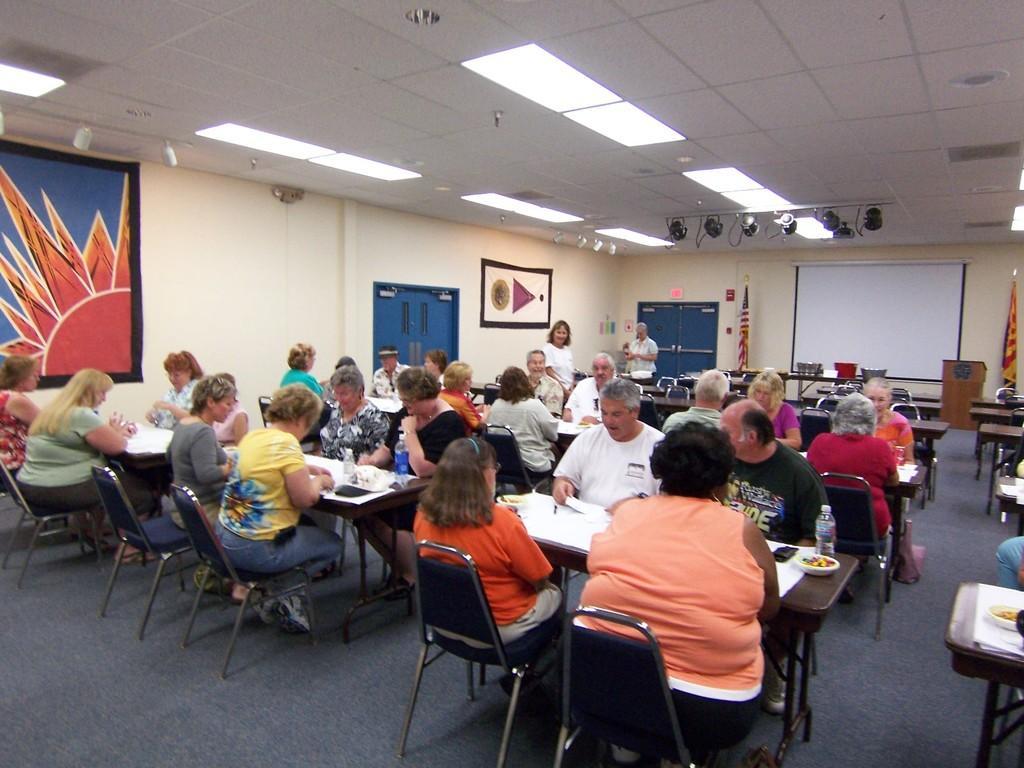How would you summarize this image in a sentence or two? In this image we can see persons sitting and standing on the chairs and tables are placed in front of them. On the tables we can see tablecloths, disposable tumblers and serving plates with food on them. In the background there are pictures pasted on the walls, cupboards, projector display, electric lights and a podium on the dais. 